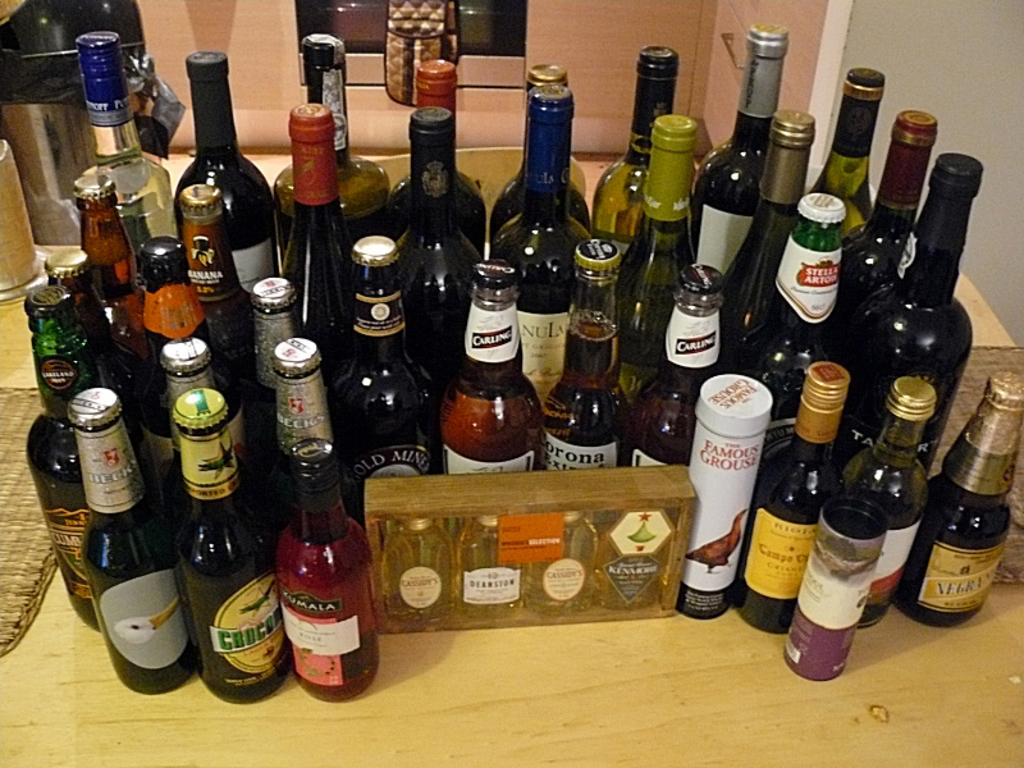<image>
Summarize the visual content of the image. Several bottles of liquor are displayed on a wood surface, including Carling, Corona, and Famous Grouse. 